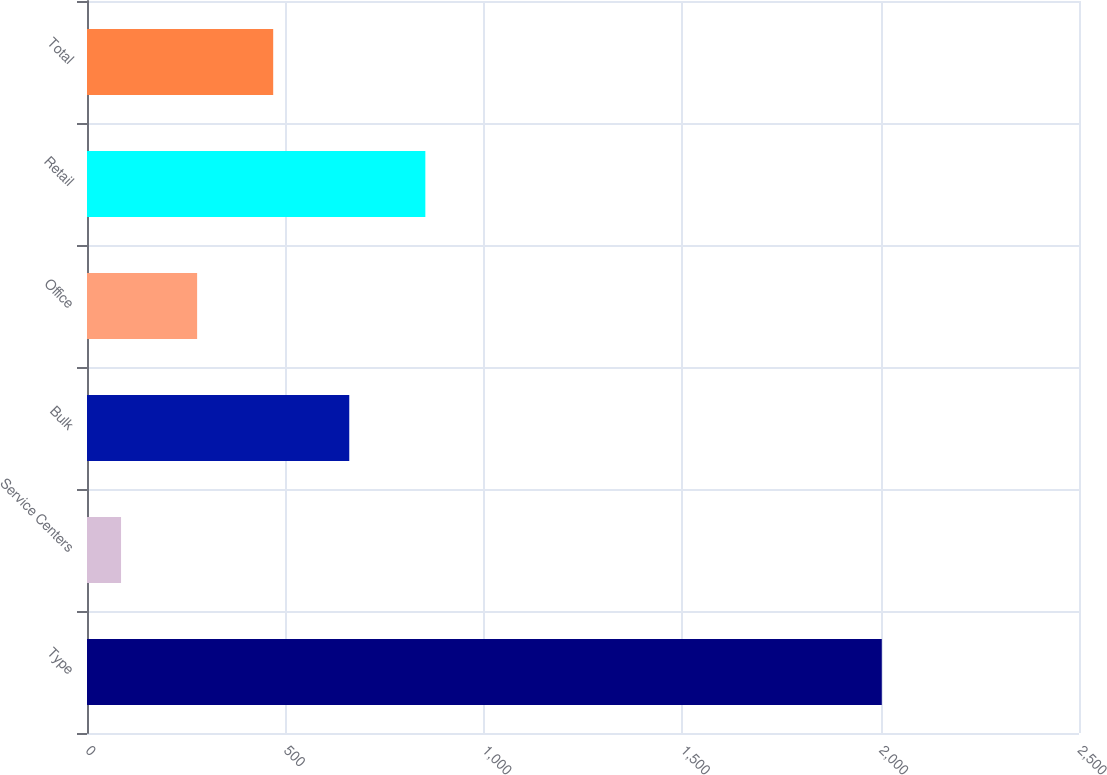<chart> <loc_0><loc_0><loc_500><loc_500><bar_chart><fcel>Type<fcel>Service Centers<fcel>Bulk<fcel>Office<fcel>Retail<fcel>Total<nl><fcel>2003<fcel>85.8<fcel>660.96<fcel>277.52<fcel>852.68<fcel>469.24<nl></chart> 